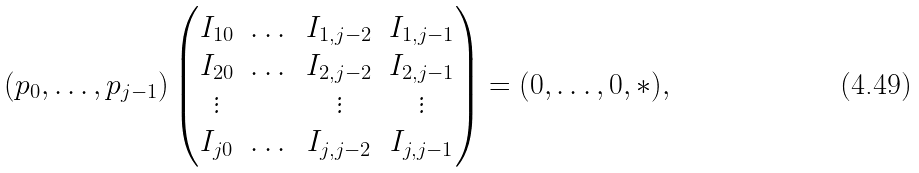Convert formula to latex. <formula><loc_0><loc_0><loc_500><loc_500>( p _ { 0 } , \dots , p _ { j - 1 } ) \begin{pmatrix} I _ { 1 0 } & \dots & I _ { 1 , j - 2 } & I _ { 1 , j - 1 } \\ I _ { 2 0 } & \dots & I _ { 2 , j - 2 } & I _ { 2 , j - 1 } \\ \vdots & & \vdots & \vdots \\ I _ { j 0 } & \dots & I _ { j , j - 2 } & I _ { j , j - 1 } \\ \end{pmatrix} = ( 0 , \dots , 0 , * ) ,</formula> 